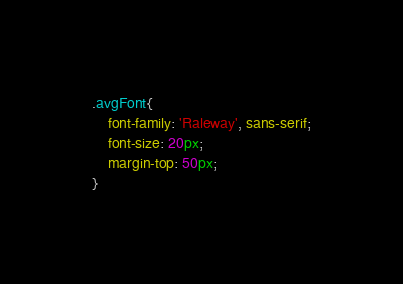<code> <loc_0><loc_0><loc_500><loc_500><_CSS_>.avgFont{
    font-family: 'Raleway', sans-serif;
    font-size: 20px;
    margin-top: 50px;
}</code> 